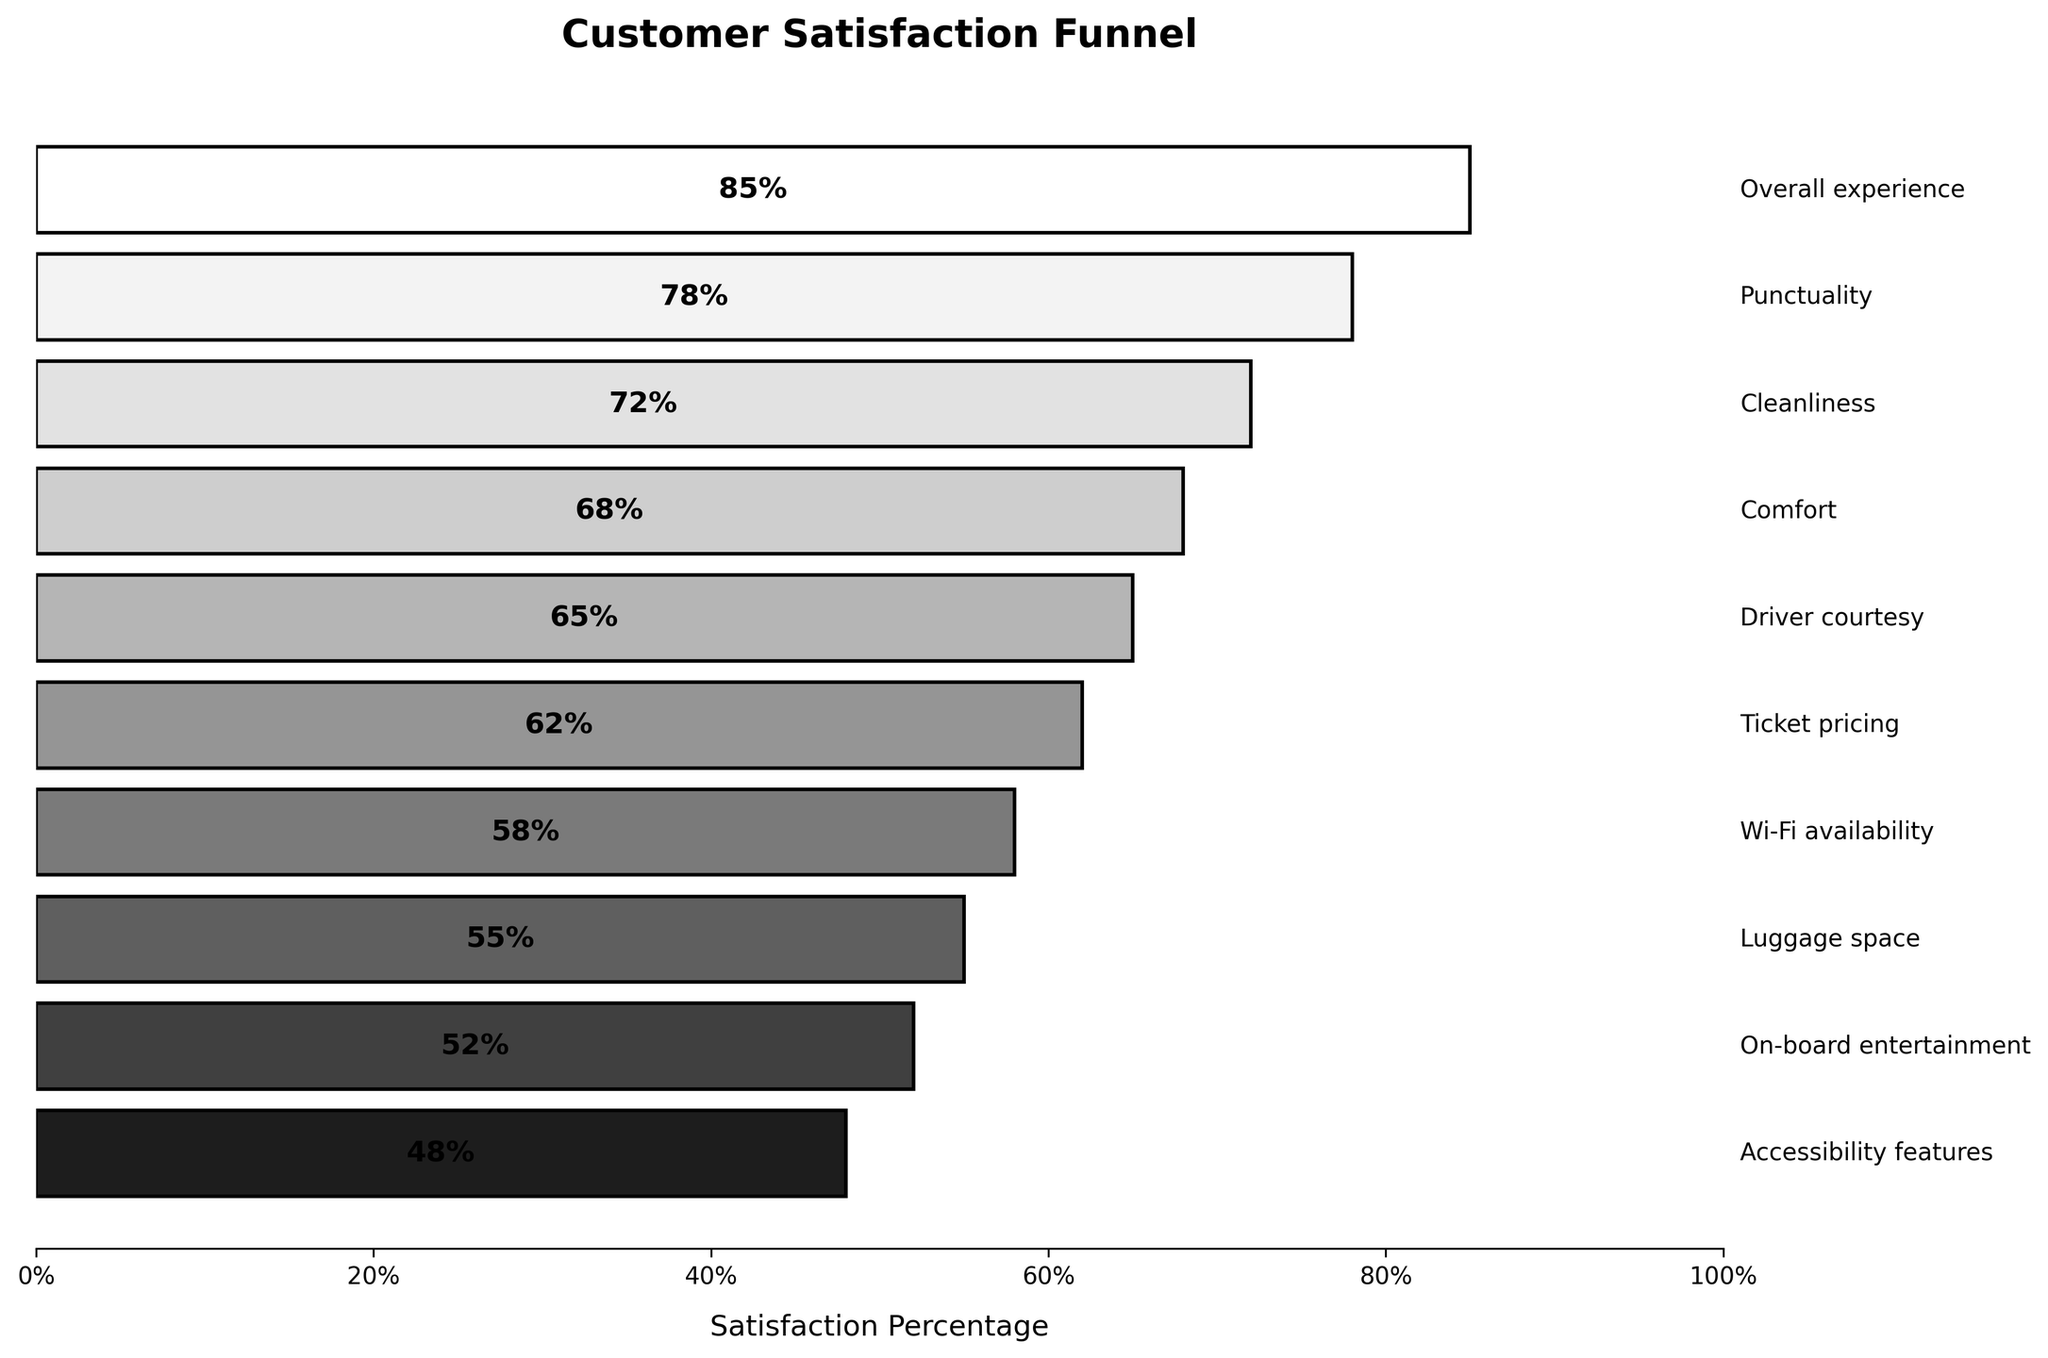What is the title of the plot? The title is typically displayed at the top of the plot in a larger and bold font to summarize the chart's content. The plot shows "Customer Satisfaction Funnel" as its title.
Answer: Customer Satisfaction Funnel Which aspect has the highest satisfaction percentage? The highest satisfaction percentage is where the funnel is the widest and listed first from the top since the funnel chart typically lists items from highest to lowest. "Overall experience" is the top aspect with the highest satisfaction percentage of 85%.
Answer: Overall experience What is the satisfaction percentage for Wi-Fi availability? Locate the bar labeled "Wi-Fi availability". The percentage is displayed inside the bar. In this case, "Wi-Fi availability" has a satisfaction percentage of 58%.
Answer: 58% Which aspect has the lowest satisfaction percentage, and what is that percentage? The lowest satisfaction percentage appears at the bottom of the funnel. In this plot, "Accessibility features" is at the bottom with 48% satisfaction.
Answer: Accessibility features, 48% How does the satisfaction percentage for Cleanliness compare to Comfort? Find the satisfaction percentages for Cleanliness (72%) and Comfort (68%). Compare and see that Cleanliness is higher than Comfort.
Answer: Cleanliness is higher than Comfort What is the average satisfaction percentage for Driver courtesy, Ticket pricing, and Wi-Fi availability? Combine the satisfaction percentages for Driver courtesy (65%), Ticket pricing (62%), and Wi-Fi availability (58%). Then calculate the average: (65 + 62 + 58) / 3 = 61.67.
Answer: 61.67 How many aspects are depicted in the plot? Count the number of distinct bars or labels representing different aspects in the funnel chart. There are 10 aspects listed.
Answer: 10 Which three aspects have the closest satisfaction percentages, and what are those values? Identify aspects with satisfaction percentages that are numerically close: Driver courtesy (65%), Ticket pricing (62%), and Wi-Fi availability (58%).
Answer: Driver courtesy (65%), Ticket pricing (62%), Wi-Fi availability (58%) What is the range of satisfaction percentages in the plot? Calculate the range by subtracting the lowest percentage (Accessibility features, 48%) from the highest percentage (Overall experience, 85%): 85 - 48 = 37.
Answer: 37 If the plot is ordered by satisfaction percentage, what aspect is directly above and below Punctuality? Find Punctuality with 78% and then see that "Overall experience" (85%) is above it and "Cleanliness" (72%) is below it.
Answer: Overall experience is above, Cleanliness is below 